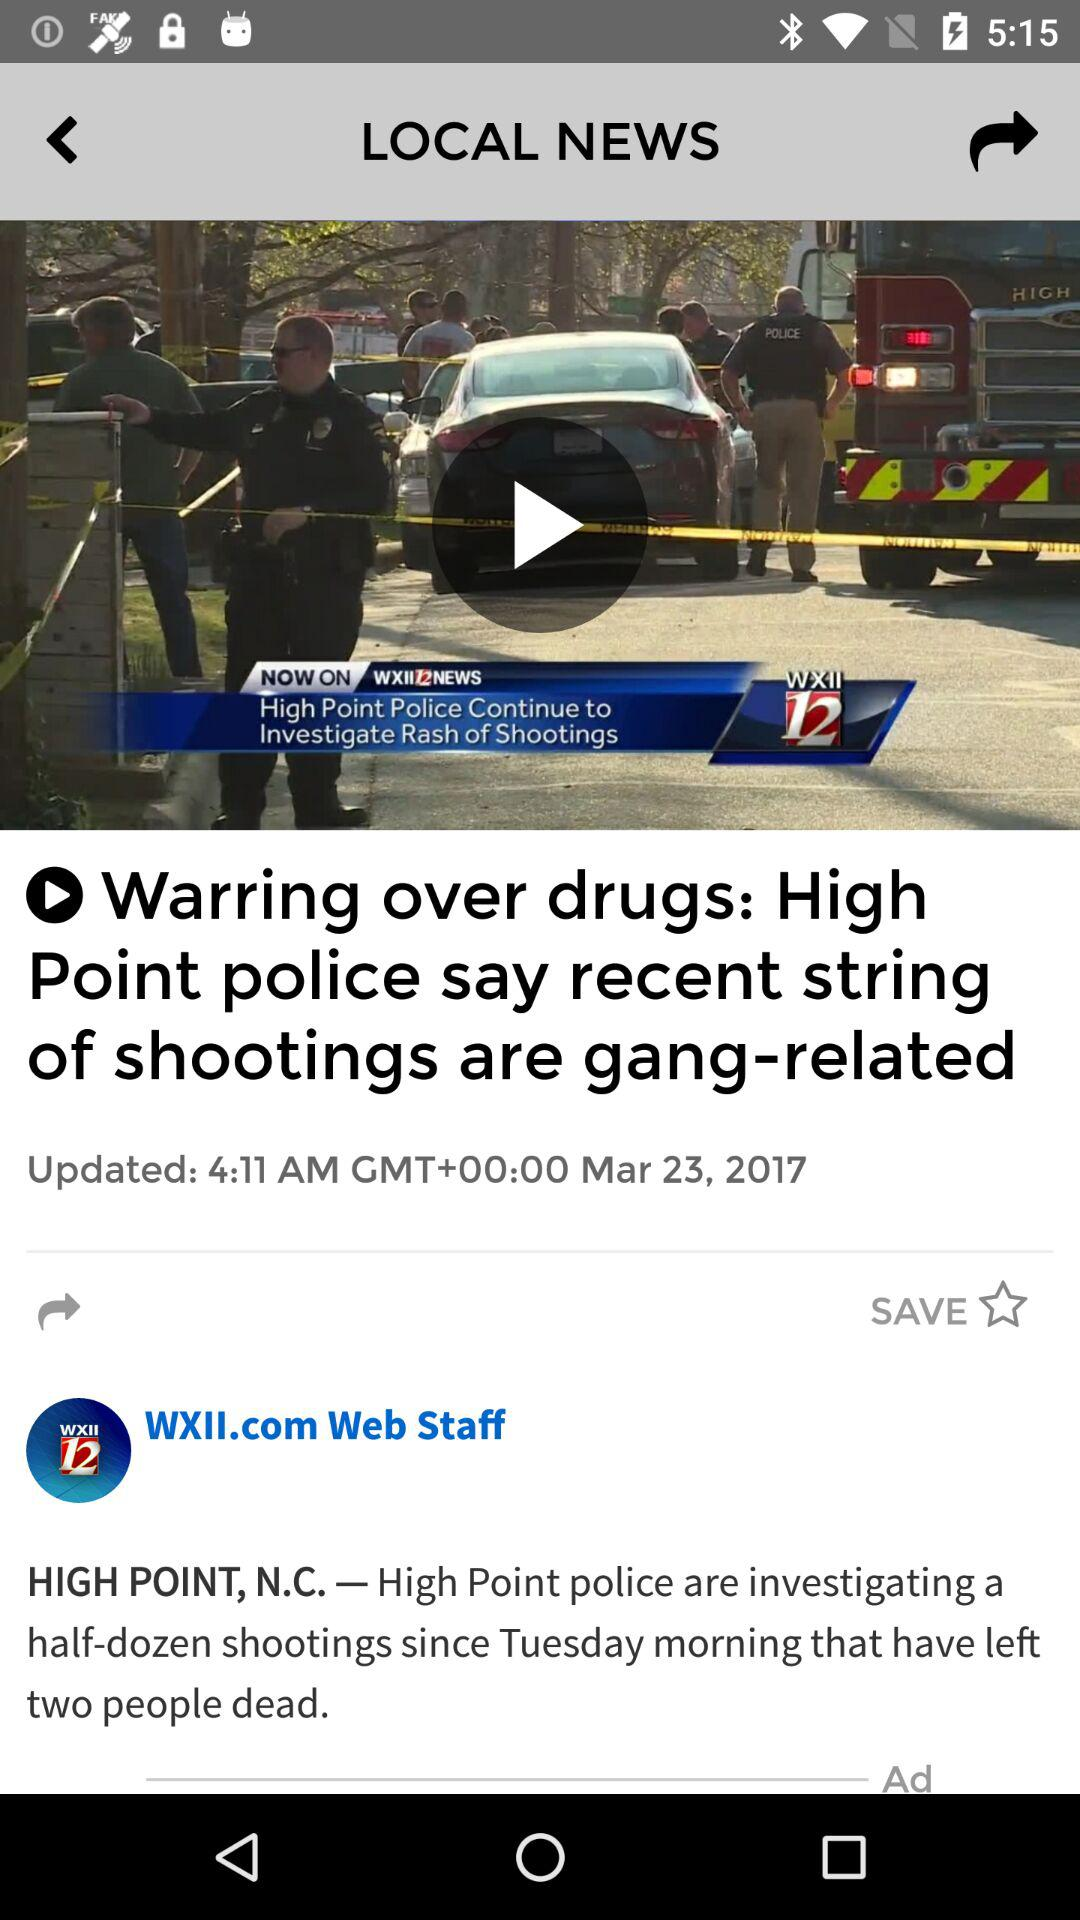What is the updated date of the article? The updated date is March 23, 2017. 